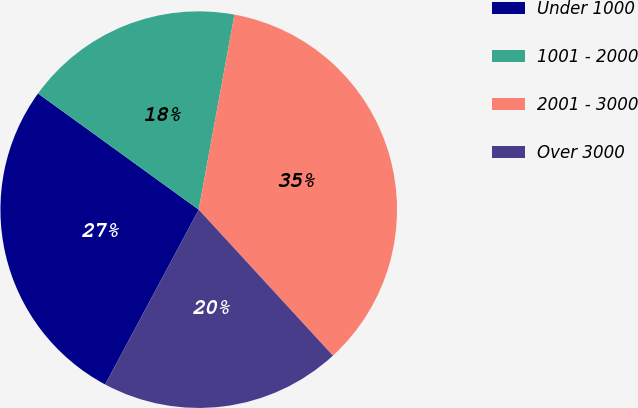Convert chart. <chart><loc_0><loc_0><loc_500><loc_500><pie_chart><fcel>Under 1000<fcel>1001 - 2000<fcel>2001 - 3000<fcel>Over 3000<nl><fcel>27.14%<fcel>17.92%<fcel>35.29%<fcel>19.65%<nl></chart> 